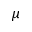<formula> <loc_0><loc_0><loc_500><loc_500>\mu</formula> 